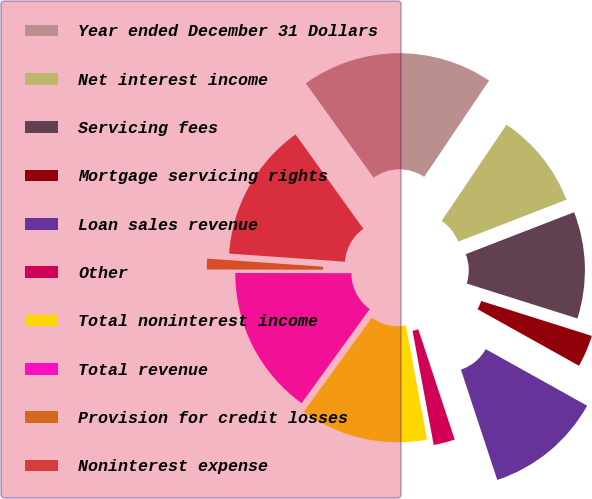Convert chart to OTSL. <chart><loc_0><loc_0><loc_500><loc_500><pie_chart><fcel>Year ended December 31 Dollars<fcel>Net interest income<fcel>Servicing fees<fcel>Mortgage servicing rights<fcel>Loan sales revenue<fcel>Other<fcel>Total noninterest income<fcel>Total revenue<fcel>Provision for credit losses<fcel>Noninterest expense<nl><fcel>19.35%<fcel>9.68%<fcel>10.75%<fcel>3.23%<fcel>11.83%<fcel>2.15%<fcel>12.9%<fcel>15.05%<fcel>1.08%<fcel>13.98%<nl></chart> 